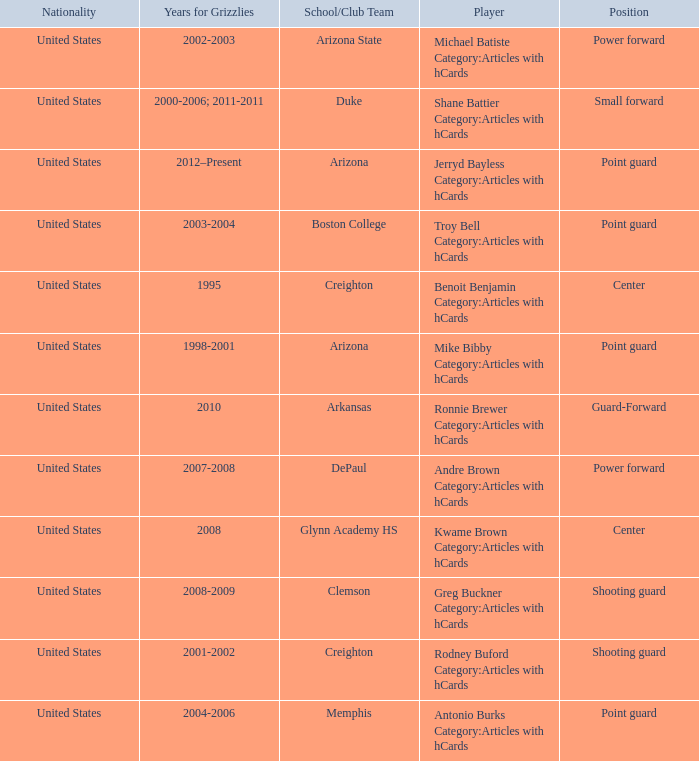Could you parse the entire table as a dict? {'header': ['Nationality', 'Years for Grizzlies', 'School/Club Team', 'Player', 'Position'], 'rows': [['United States', '2002-2003', 'Arizona State', 'Michael Batiste Category:Articles with hCards', 'Power forward'], ['United States', '2000-2006; 2011-2011', 'Duke', 'Shane Battier Category:Articles with hCards', 'Small forward'], ['United States', '2012–Present', 'Arizona', 'Jerryd Bayless Category:Articles with hCards', 'Point guard'], ['United States', '2003-2004', 'Boston College', 'Troy Bell Category:Articles with hCards', 'Point guard'], ['United States', '1995', 'Creighton', 'Benoit Benjamin Category:Articles with hCards', 'Center'], ['United States', '1998-2001', 'Arizona', 'Mike Bibby Category:Articles with hCards', 'Point guard'], ['United States', '2010', 'Arkansas', 'Ronnie Brewer Category:Articles with hCards', 'Guard-Forward'], ['United States', '2007-2008', 'DePaul', 'Andre Brown Category:Articles with hCards', 'Power forward'], ['United States', '2008', 'Glynn Academy HS', 'Kwame Brown Category:Articles with hCards', 'Center'], ['United States', '2008-2009', 'Clemson', 'Greg Buckner Category:Articles with hCards', 'Shooting guard'], ['United States', '2001-2002', 'Creighton', 'Rodney Buford Category:Articles with hCards', 'Shooting guard'], ['United States', '2004-2006', 'Memphis', 'Antonio Burks Category:Articles with hCards', 'Point guard']]} Which Player has Years for Grizzlies of 2002-2003? Michael Batiste Category:Articles with hCards. 